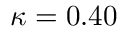<formula> <loc_0><loc_0><loc_500><loc_500>\kappa = 0 . 4 0</formula> 